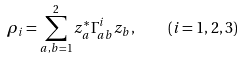Convert formula to latex. <formula><loc_0><loc_0><loc_500><loc_500>\rho _ { i } = \sum ^ { 2 } _ { a , b = 1 } z ^ { * } _ { a } \Gamma ^ { i } _ { a b } z _ { b } , \quad ( i = 1 , 2 , 3 )</formula> 